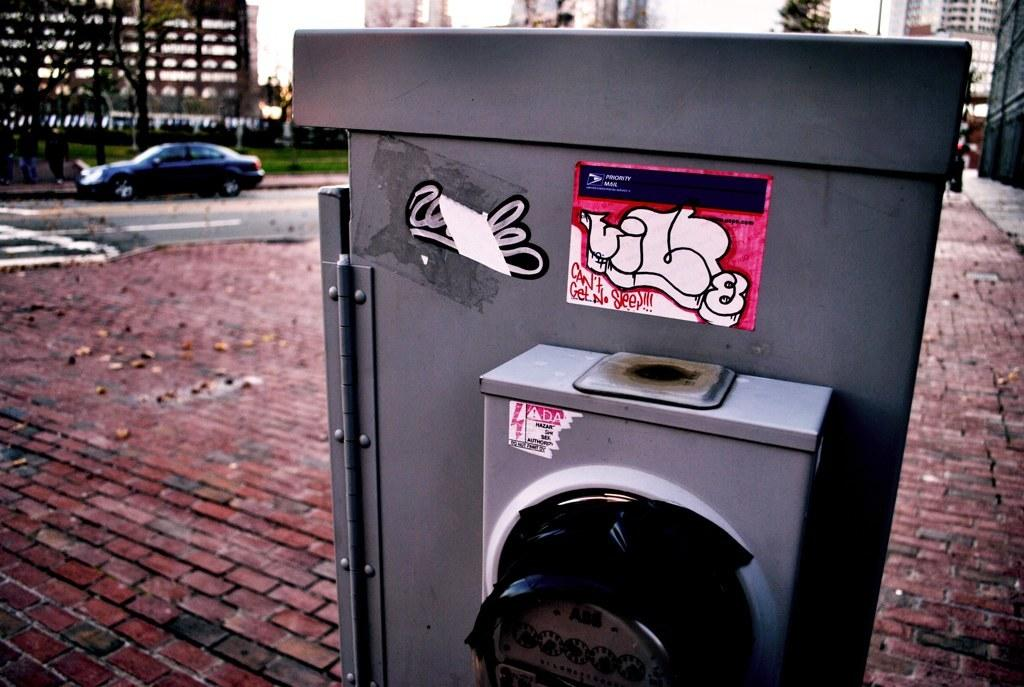Provide a one-sentence caption for the provided image. COntainer outdoors with a graffiti on it which says Can't Get No Sleep. 